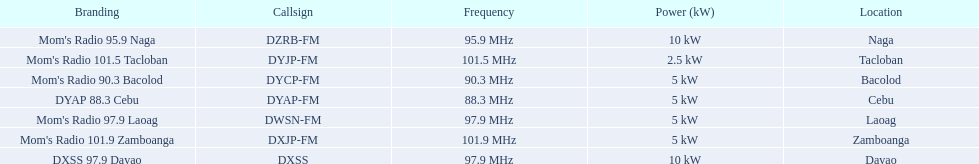Which stations broadcast in dyap-fm? Mom's Radio 97.9 Laoag, Mom's Radio 95.9 Naga, Mom's Radio 90.3 Bacolod, DYAP 88.3 Cebu, Mom's Radio 101.5 Tacloban, Mom's Radio 101.9 Zamboanga, DXSS 97.9 Davao. Of those stations which broadcast in dyap-fm, which stations broadcast with 5kw of power or under? Mom's Radio 97.9 Laoag, Mom's Radio 90.3 Bacolod, DYAP 88.3 Cebu, Mom's Radio 101.5 Tacloban, Mom's Radio 101.9 Zamboanga. Of those stations that broadcast with 5kw of power or under, which broadcasts with the least power? Mom's Radio 101.5 Tacloban. 